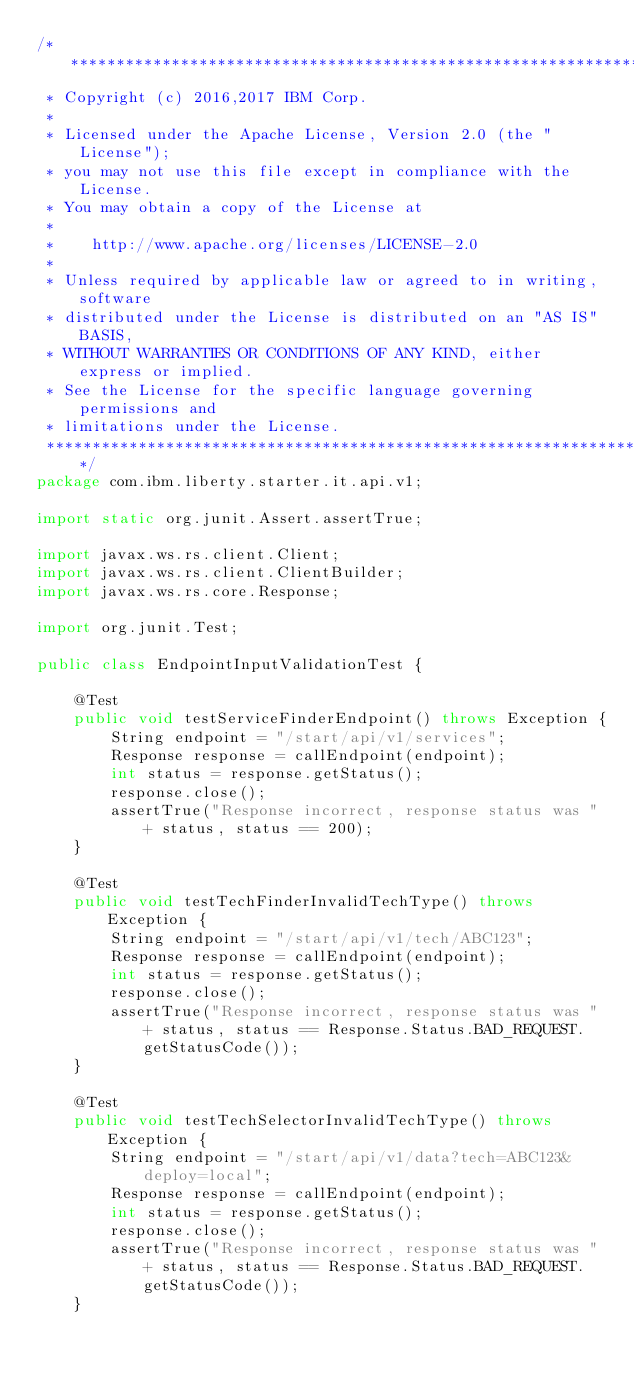Convert code to text. <code><loc_0><loc_0><loc_500><loc_500><_Java_>/*******************************************************************************
 * Copyright (c) 2016,2017 IBM Corp.
 *
 * Licensed under the Apache License, Version 2.0 (the "License");
 * you may not use this file except in compliance with the License.
 * You may obtain a copy of the License at
 *
 *    http://www.apache.org/licenses/LICENSE-2.0
 *
 * Unless required by applicable law or agreed to in writing, software
 * distributed under the License is distributed on an "AS IS" BASIS,
 * WITHOUT WARRANTIES OR CONDITIONS OF ANY KIND, either express or implied.
 * See the License for the specific language governing permissions and
 * limitations under the License.
 *******************************************************************************/
package com.ibm.liberty.starter.it.api.v1;

import static org.junit.Assert.assertTrue;

import javax.ws.rs.client.Client;
import javax.ws.rs.client.ClientBuilder;
import javax.ws.rs.core.Response;

import org.junit.Test;

public class EndpointInputValidationTest {
    
    @Test
    public void testServiceFinderEndpoint() throws Exception {
        String endpoint = "/start/api/v1/services";
        Response response = callEndpoint(endpoint);
        int status = response.getStatus();
        response.close();
        assertTrue("Response incorrect, response status was " + status, status == 200);
    }

    @Test
    public void testTechFinderInvalidTechType() throws Exception {
        String endpoint = "/start/api/v1/tech/ABC123";
        Response response = callEndpoint(endpoint);
        int status = response.getStatus();
        response.close();
        assertTrue("Response incorrect, response status was " + status, status == Response.Status.BAD_REQUEST.getStatusCode());
    }

    @Test
    public void testTechSelectorInvalidTechType() throws Exception {
        String endpoint = "/start/api/v1/data?tech=ABC123&deploy=local";
        Response response = callEndpoint(endpoint);
        int status = response.getStatus();
        response.close();
        assertTrue("Response incorrect, response status was " + status, status == Response.Status.BAD_REQUEST.getStatusCode());
    }
</code> 